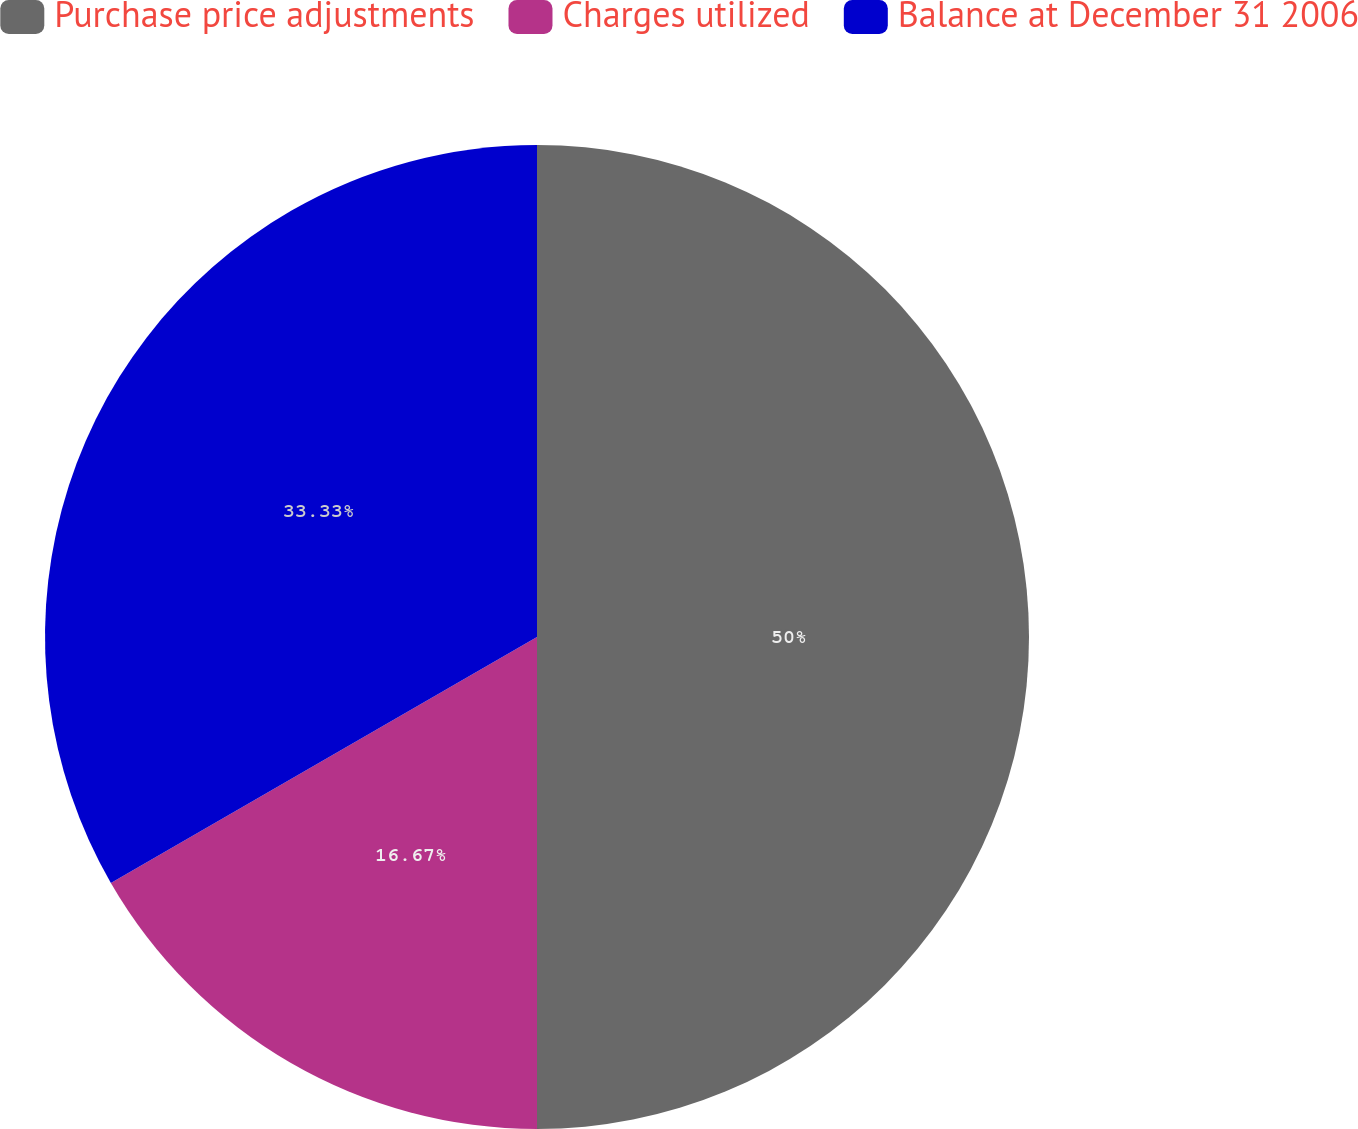Convert chart to OTSL. <chart><loc_0><loc_0><loc_500><loc_500><pie_chart><fcel>Purchase price adjustments<fcel>Charges utilized<fcel>Balance at December 31 2006<nl><fcel>50.0%<fcel>16.67%<fcel>33.33%<nl></chart> 